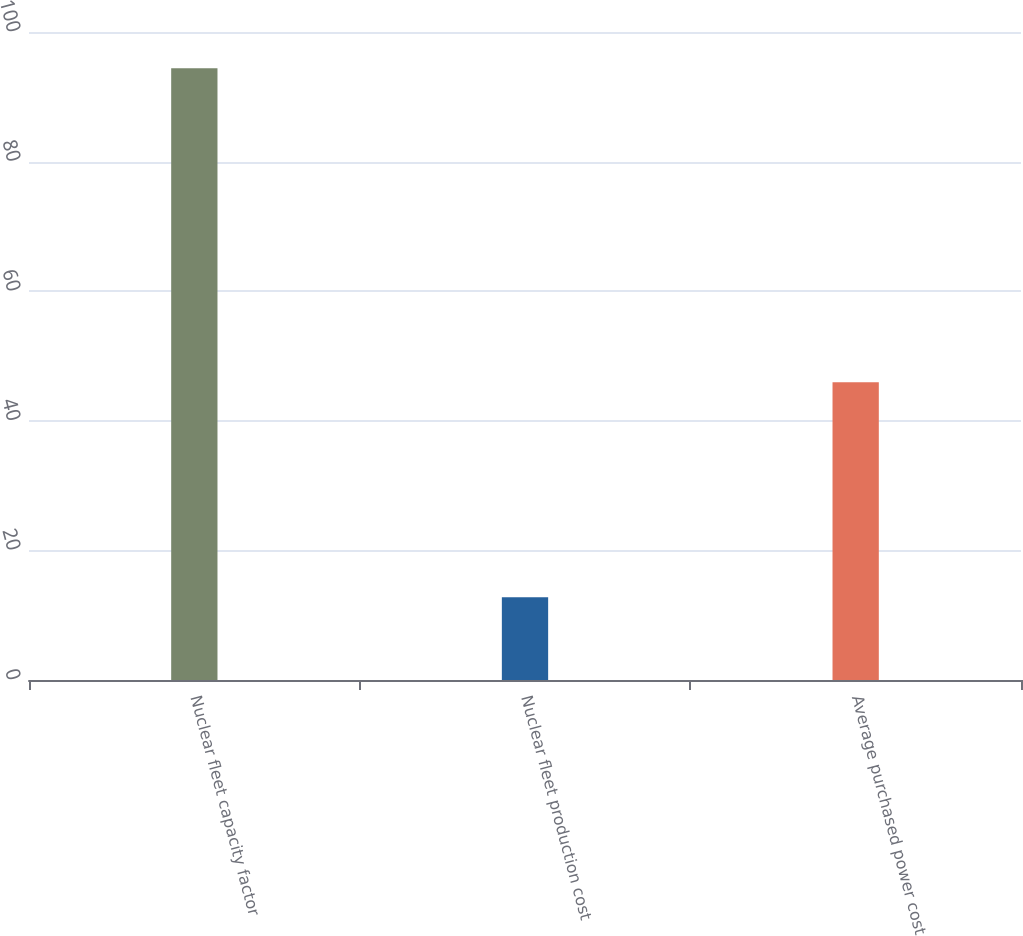<chart> <loc_0><loc_0><loc_500><loc_500><bar_chart><fcel>Nuclear fleet capacity factor<fcel>Nuclear fleet production cost<fcel>Average purchased power cost<nl><fcel>94.4<fcel>12.78<fcel>45.94<nl></chart> 